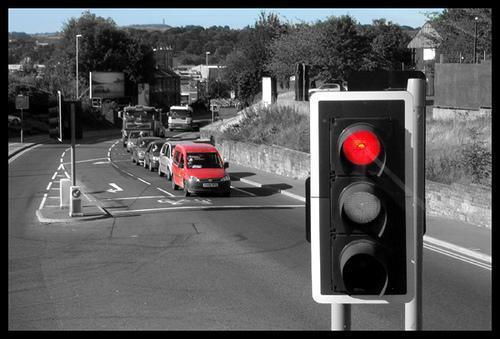How many buses are in the picture?
Give a very brief answer. 0. 